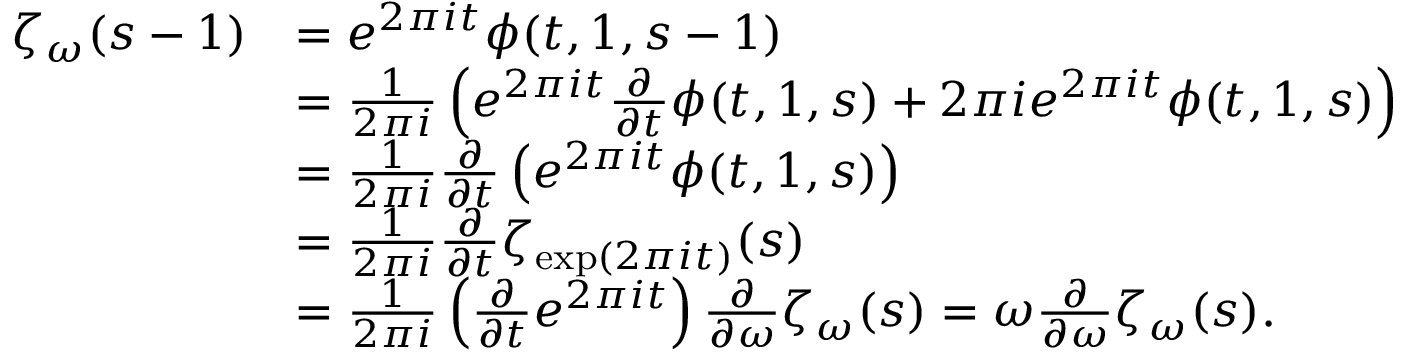Convert formula to latex. <formula><loc_0><loc_0><loc_500><loc_500>\begin{array} { r l } { \zeta _ { \omega } ( s - 1 ) } & { = e ^ { 2 \pi i t } \phi ( t , 1 , s - 1 ) } \\ & { = \frac { 1 } { 2 \pi i } \left ( e ^ { 2 \pi i t } \frac { \partial } { \partial t } \phi ( t , 1 , s ) + 2 \pi i e ^ { 2 \pi i t } \phi ( t , 1 , s ) \right ) } \\ & { = \frac { 1 } { 2 \pi i } \frac { \partial } { \partial t } \left ( e ^ { 2 \pi i t } \phi ( t , 1 , s ) \right ) } \\ & { = \frac { 1 } { 2 \pi i } \frac { \partial } { \partial t } \zeta _ { \exp ( 2 \pi i t ) } ( s ) } \\ & { = \frac { 1 } { 2 \pi i } \left ( \frac { \partial } { \partial t } e ^ { 2 \pi i t } \right ) \frac { \partial } { \partial \omega } \zeta _ { \omega } ( s ) = \omega \frac { \partial } { \partial \omega } \zeta _ { \omega } ( s ) . } \end{array}</formula> 